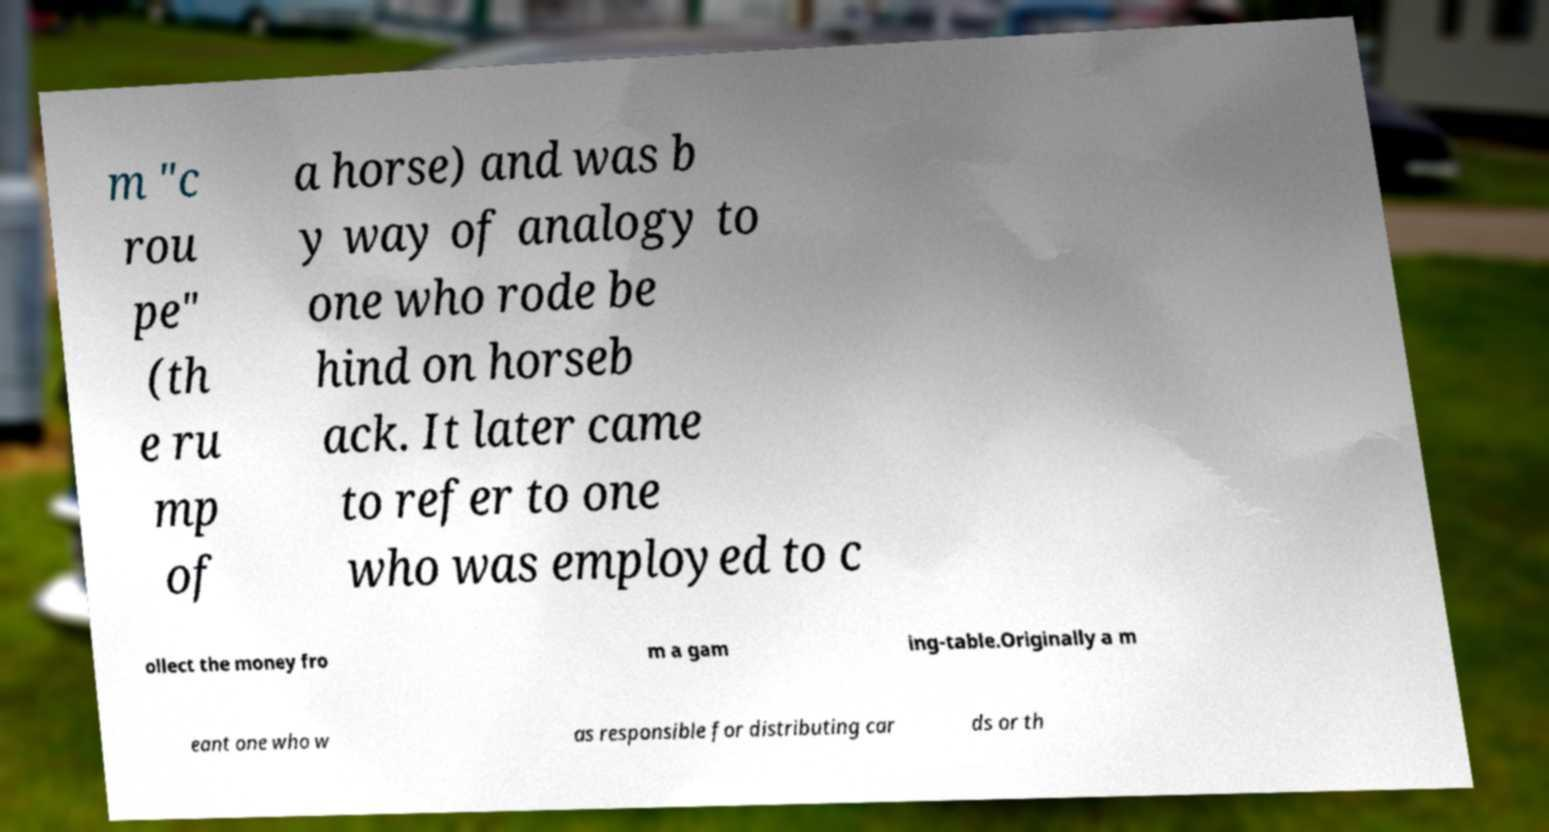There's text embedded in this image that I need extracted. Can you transcribe it verbatim? m "c rou pe" (th e ru mp of a horse) and was b y way of analogy to one who rode be hind on horseb ack. It later came to refer to one who was employed to c ollect the money fro m a gam ing-table.Originally a m eant one who w as responsible for distributing car ds or th 